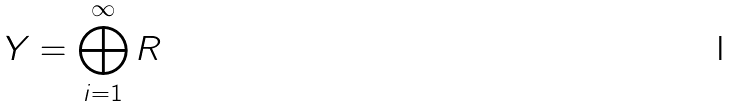Convert formula to latex. <formula><loc_0><loc_0><loc_500><loc_500>Y = \bigoplus _ { i = 1 } ^ { \infty } R</formula> 